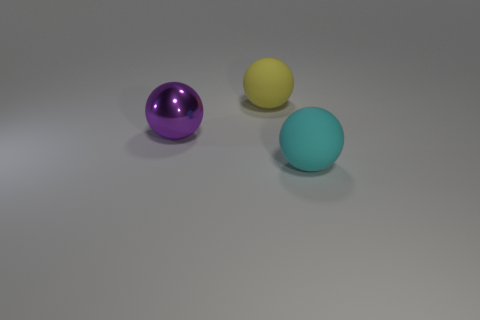Subtract all big yellow rubber spheres. How many spheres are left? 2 Subtract all cyan balls. How many balls are left? 2 Add 3 metallic things. How many objects exist? 6 Subtract 1 spheres. How many spheres are left? 2 Add 1 large yellow matte things. How many large yellow matte things are left? 2 Add 3 large cyan rubber things. How many large cyan rubber things exist? 4 Subtract 0 brown cylinders. How many objects are left? 3 Subtract all gray balls. Subtract all green cylinders. How many balls are left? 3 Subtract all gray cubes. How many yellow spheres are left? 1 Subtract all large purple things. Subtract all cyan rubber balls. How many objects are left? 1 